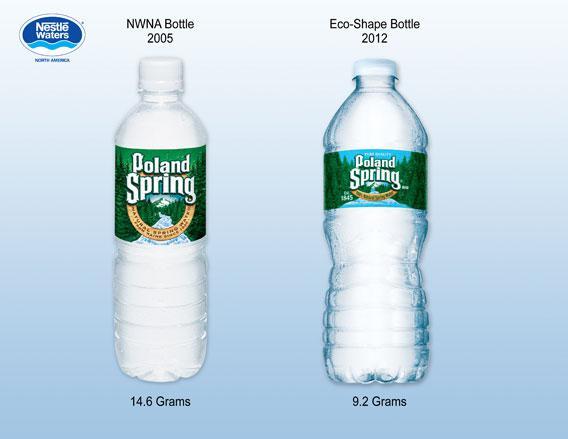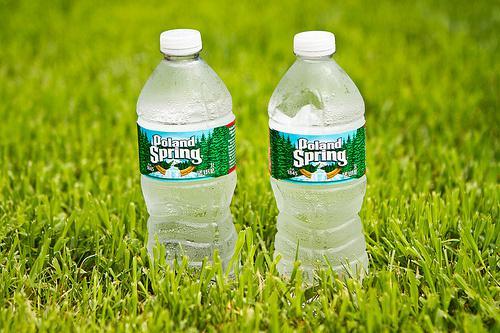The first image is the image on the left, the second image is the image on the right. For the images shown, is this caption "At least one image shows a large mass of water bottles." true? Answer yes or no. No. 